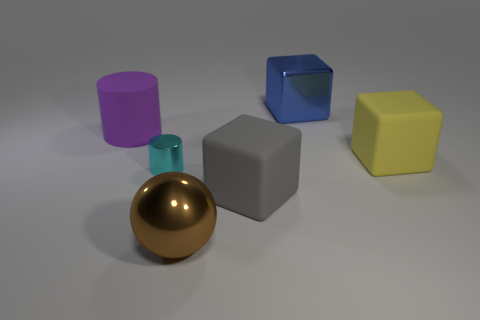How would you describe the lighting in this image? The lighting in this image seems soft and diffused, casting gentle shadows on the right side of the objects while highlighting their left. It creates a calm ambiance and enhances the perception of the objects' shapes and materials without creating harsh reflections or overexposed areas. 